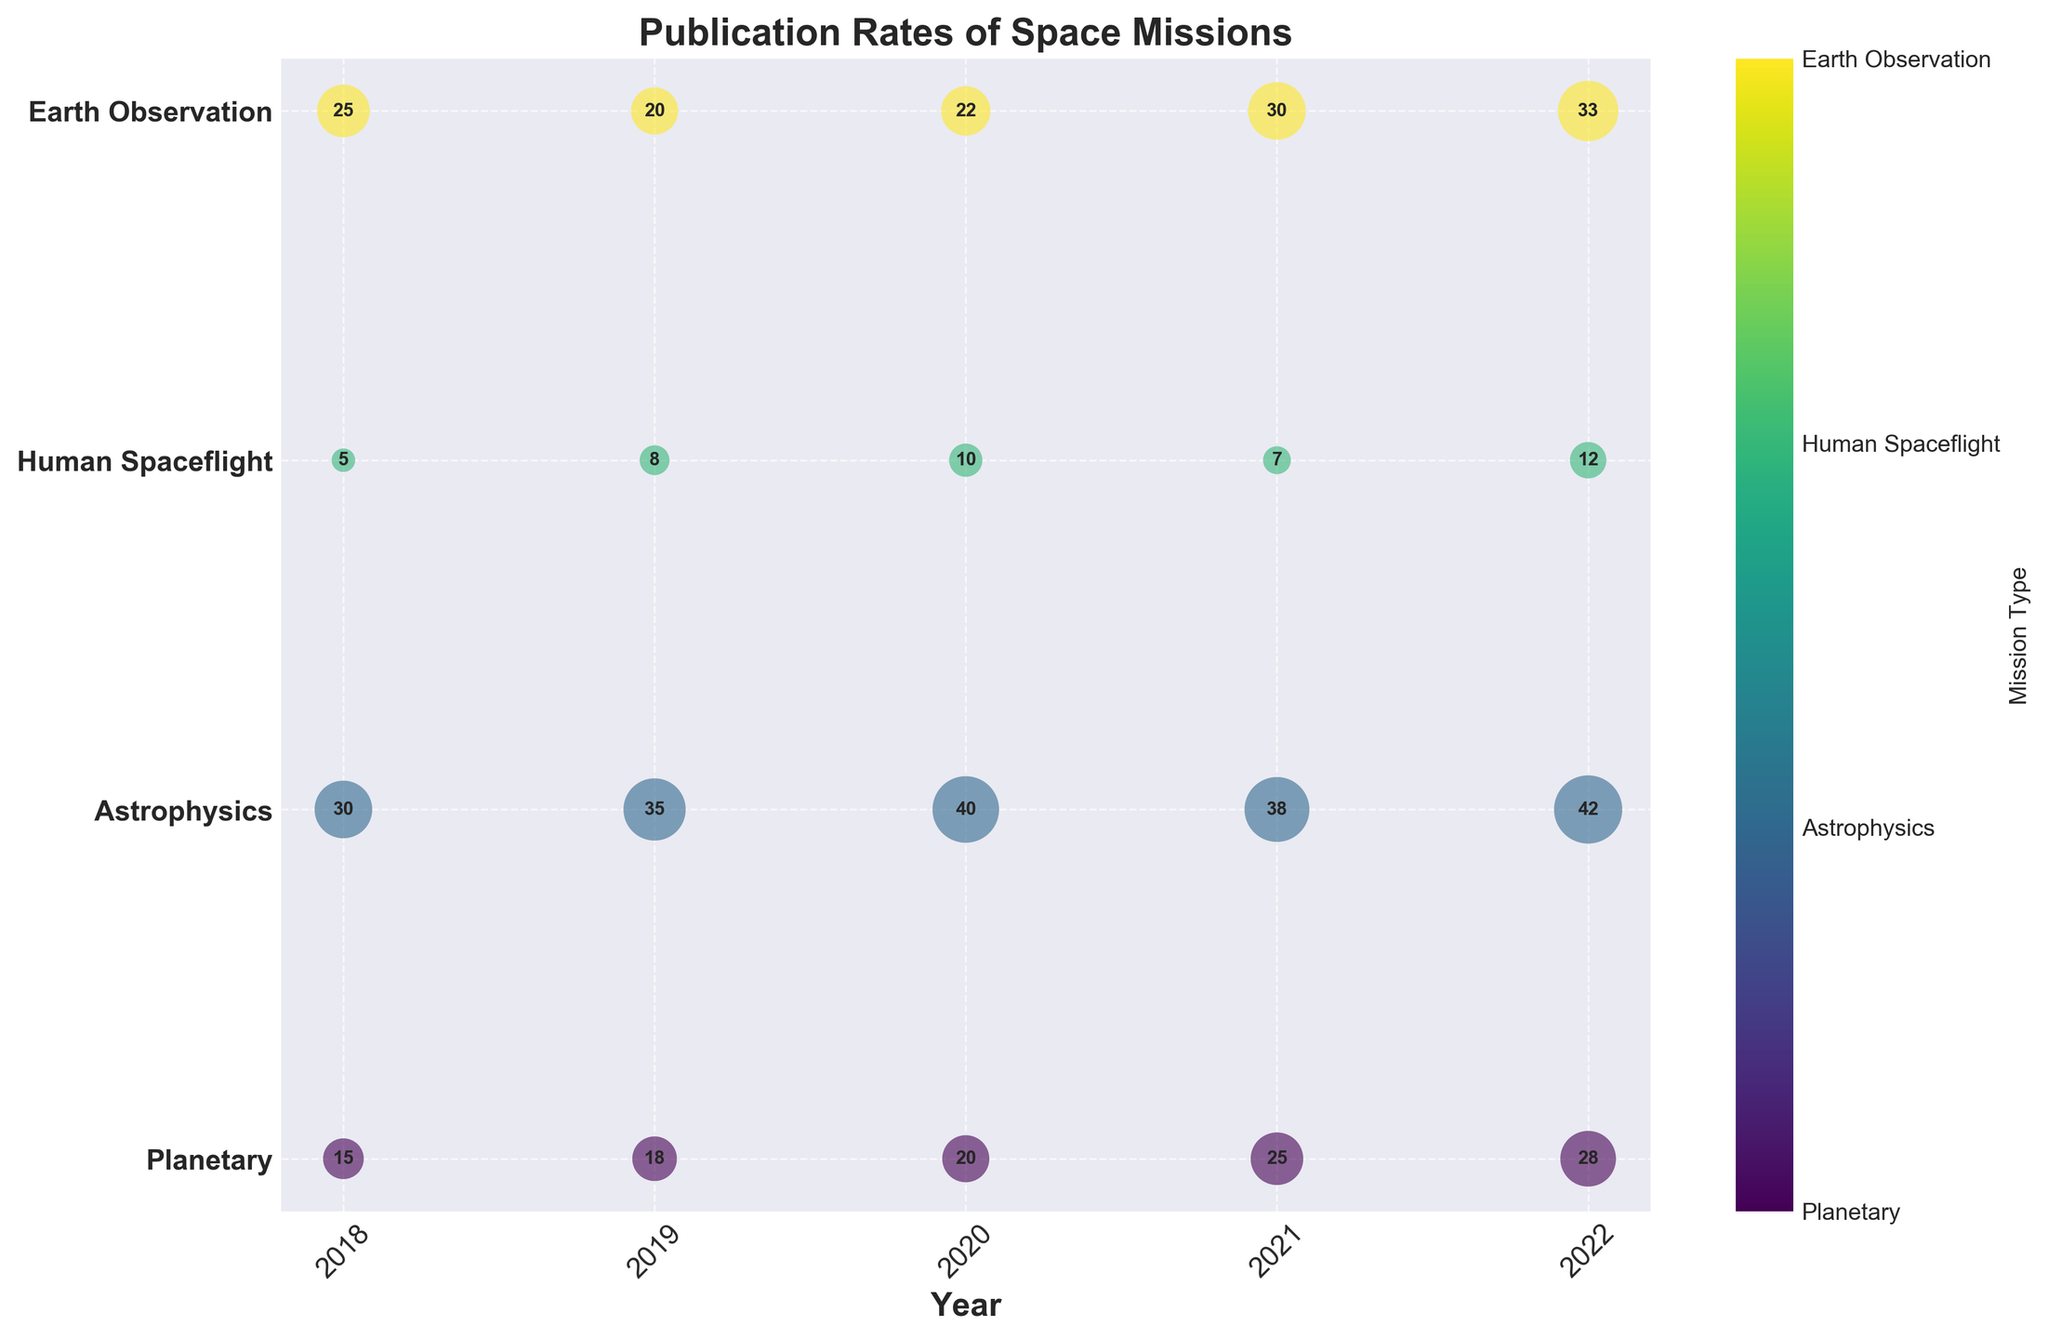What is the title of the plot? The title of the plot is displayed at the top of the figure. It is in a bold font to distinguish it from other text elements.
Answer: Publication Rates of Space Missions Which year had the most publications overall? By visually comparing the size of the bubbles for each year, 2022 has the largest bubbles in total, indicating the highest number of publications.
Answer: 2022 Which mission type saw a decrease in the number of publications from 2021 to 2022? By comparing the sizes of the bubbles for each mission type between the years 2021 and 2022, it is evident that Human Spaceflight saw a decrease in the number of publications.
Answer: Human Spaceflight What was the total number of publications in 2020? By summing the number of publications across all mission types in 2020: 20 (Planetary) + 40 (Astrophysics) + 10 (Human Spaceflight) + 22 (Earth Observation) = 92.
Answer: 92 Which mission type had the highest number of publications in 2018? By comparing the size of the bubbles for different mission types in 2018, Astrophysics had the largest bubble, indicating the highest number of publications.
Answer: Astrophysics How does the publication trend of Earth Observation compare from 2018 to 2022? By observing the changes in bubble size for Earth Observation from 2018 to 2022, the trend shows an overall increase from 25 in 2018 to 33 in 2022.
Answer: Increasing What is the average number of publications per year for Human Spaceflight from 2019 to 2021? By adding the number of publications for Human Spaceflight from 2019 to 2021: 8 (2019) + 10 (2020) + 7 (2021) = 25. The average is 25 / 3 = 8.33.
Answer: 8.33 Which mission type had the most significant increase in publications from 2020 to 2021? By comparing the difference in bubble sizes from 2020 to 2021 for each mission type, Planetary had the largest increase from 20 to 25.
Answer: Planetary What is the general trend for Astrophysics publications from 2018 to 2022? By looking at the bubble sizes for Astrophysics from 2018 to 2022, the trend shows a consistent increase from 30 in 2018 to 42 in 2022.
Answer: Increasing In which year did Planetary missions see the largest number of publications? By comparing the sizes of all the bubbles for Planetary missions from each year, 2022 had the largest bubble with 28 publications.
Answer: 2022 